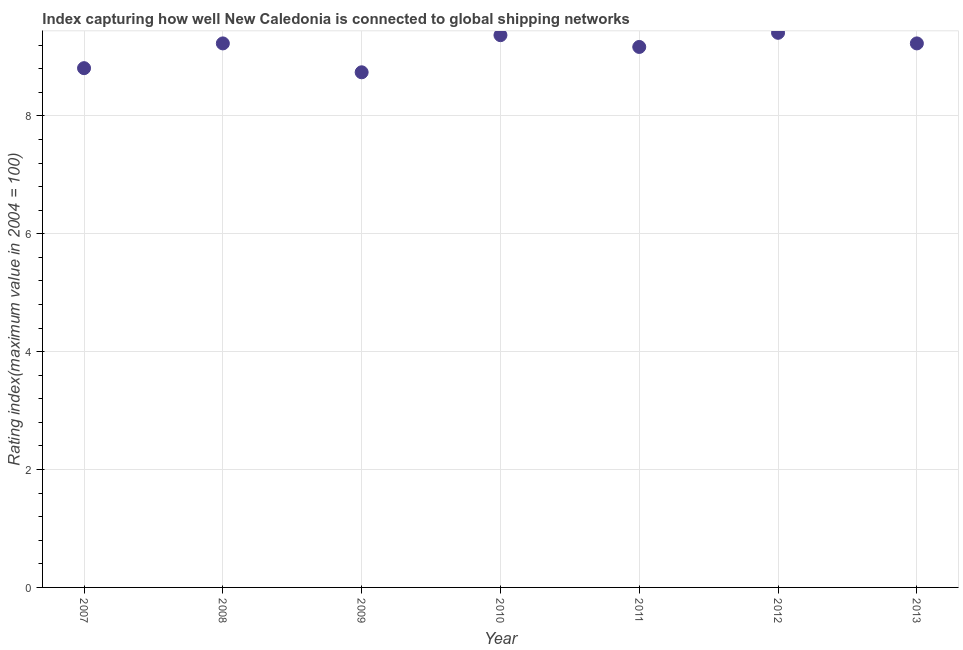What is the liner shipping connectivity index in 2011?
Keep it short and to the point. 9.17. Across all years, what is the maximum liner shipping connectivity index?
Provide a short and direct response. 9.41. Across all years, what is the minimum liner shipping connectivity index?
Your answer should be compact. 8.74. In which year was the liner shipping connectivity index maximum?
Your answer should be compact. 2012. In which year was the liner shipping connectivity index minimum?
Give a very brief answer. 2009. What is the sum of the liner shipping connectivity index?
Your response must be concise. 63.96. What is the difference between the liner shipping connectivity index in 2009 and 2010?
Provide a succinct answer. -0.63. What is the average liner shipping connectivity index per year?
Provide a short and direct response. 9.14. What is the median liner shipping connectivity index?
Your answer should be compact. 9.23. In how many years, is the liner shipping connectivity index greater than 4.4 ?
Your answer should be compact. 7. Do a majority of the years between 2013 and 2007 (inclusive) have liner shipping connectivity index greater than 4.8 ?
Provide a succinct answer. Yes. What is the ratio of the liner shipping connectivity index in 2008 to that in 2012?
Provide a short and direct response. 0.98. Is the difference between the liner shipping connectivity index in 2007 and 2012 greater than the difference between any two years?
Your answer should be compact. No. What is the difference between the highest and the second highest liner shipping connectivity index?
Give a very brief answer. 0.04. Is the sum of the liner shipping connectivity index in 2008 and 2012 greater than the maximum liner shipping connectivity index across all years?
Give a very brief answer. Yes. What is the difference between the highest and the lowest liner shipping connectivity index?
Your answer should be very brief. 0.67. In how many years, is the liner shipping connectivity index greater than the average liner shipping connectivity index taken over all years?
Provide a short and direct response. 5. Does the liner shipping connectivity index monotonically increase over the years?
Ensure brevity in your answer.  No. How many dotlines are there?
Your answer should be very brief. 1. How many years are there in the graph?
Your answer should be compact. 7. What is the difference between two consecutive major ticks on the Y-axis?
Make the answer very short. 2. Does the graph contain any zero values?
Offer a very short reply. No. What is the title of the graph?
Offer a terse response. Index capturing how well New Caledonia is connected to global shipping networks. What is the label or title of the Y-axis?
Offer a very short reply. Rating index(maximum value in 2004 = 100). What is the Rating index(maximum value in 2004 = 100) in 2007?
Your answer should be compact. 8.81. What is the Rating index(maximum value in 2004 = 100) in 2008?
Your response must be concise. 9.23. What is the Rating index(maximum value in 2004 = 100) in 2009?
Offer a terse response. 8.74. What is the Rating index(maximum value in 2004 = 100) in 2010?
Keep it short and to the point. 9.37. What is the Rating index(maximum value in 2004 = 100) in 2011?
Ensure brevity in your answer.  9.17. What is the Rating index(maximum value in 2004 = 100) in 2012?
Provide a succinct answer. 9.41. What is the Rating index(maximum value in 2004 = 100) in 2013?
Your answer should be very brief. 9.23. What is the difference between the Rating index(maximum value in 2004 = 100) in 2007 and 2008?
Your answer should be very brief. -0.42. What is the difference between the Rating index(maximum value in 2004 = 100) in 2007 and 2009?
Your response must be concise. 0.07. What is the difference between the Rating index(maximum value in 2004 = 100) in 2007 and 2010?
Give a very brief answer. -0.56. What is the difference between the Rating index(maximum value in 2004 = 100) in 2007 and 2011?
Provide a succinct answer. -0.36. What is the difference between the Rating index(maximum value in 2004 = 100) in 2007 and 2013?
Make the answer very short. -0.42. What is the difference between the Rating index(maximum value in 2004 = 100) in 2008 and 2009?
Ensure brevity in your answer.  0.49. What is the difference between the Rating index(maximum value in 2004 = 100) in 2008 and 2010?
Your response must be concise. -0.14. What is the difference between the Rating index(maximum value in 2004 = 100) in 2008 and 2012?
Your answer should be very brief. -0.18. What is the difference between the Rating index(maximum value in 2004 = 100) in 2008 and 2013?
Ensure brevity in your answer.  0. What is the difference between the Rating index(maximum value in 2004 = 100) in 2009 and 2010?
Your answer should be very brief. -0.63. What is the difference between the Rating index(maximum value in 2004 = 100) in 2009 and 2011?
Provide a short and direct response. -0.43. What is the difference between the Rating index(maximum value in 2004 = 100) in 2009 and 2012?
Provide a short and direct response. -0.67. What is the difference between the Rating index(maximum value in 2004 = 100) in 2009 and 2013?
Ensure brevity in your answer.  -0.49. What is the difference between the Rating index(maximum value in 2004 = 100) in 2010 and 2012?
Your response must be concise. -0.04. What is the difference between the Rating index(maximum value in 2004 = 100) in 2010 and 2013?
Ensure brevity in your answer.  0.14. What is the difference between the Rating index(maximum value in 2004 = 100) in 2011 and 2012?
Provide a short and direct response. -0.24. What is the difference between the Rating index(maximum value in 2004 = 100) in 2011 and 2013?
Offer a terse response. -0.06. What is the difference between the Rating index(maximum value in 2004 = 100) in 2012 and 2013?
Make the answer very short. 0.18. What is the ratio of the Rating index(maximum value in 2004 = 100) in 2007 to that in 2008?
Offer a very short reply. 0.95. What is the ratio of the Rating index(maximum value in 2004 = 100) in 2007 to that in 2010?
Make the answer very short. 0.94. What is the ratio of the Rating index(maximum value in 2004 = 100) in 2007 to that in 2011?
Make the answer very short. 0.96. What is the ratio of the Rating index(maximum value in 2004 = 100) in 2007 to that in 2012?
Provide a short and direct response. 0.94. What is the ratio of the Rating index(maximum value in 2004 = 100) in 2007 to that in 2013?
Your answer should be very brief. 0.95. What is the ratio of the Rating index(maximum value in 2004 = 100) in 2008 to that in 2009?
Your response must be concise. 1.06. What is the ratio of the Rating index(maximum value in 2004 = 100) in 2008 to that in 2010?
Give a very brief answer. 0.98. What is the ratio of the Rating index(maximum value in 2004 = 100) in 2008 to that in 2011?
Your response must be concise. 1.01. What is the ratio of the Rating index(maximum value in 2004 = 100) in 2009 to that in 2010?
Make the answer very short. 0.93. What is the ratio of the Rating index(maximum value in 2004 = 100) in 2009 to that in 2011?
Give a very brief answer. 0.95. What is the ratio of the Rating index(maximum value in 2004 = 100) in 2009 to that in 2012?
Provide a succinct answer. 0.93. What is the ratio of the Rating index(maximum value in 2004 = 100) in 2009 to that in 2013?
Ensure brevity in your answer.  0.95. What is the ratio of the Rating index(maximum value in 2004 = 100) in 2010 to that in 2012?
Offer a terse response. 1. 